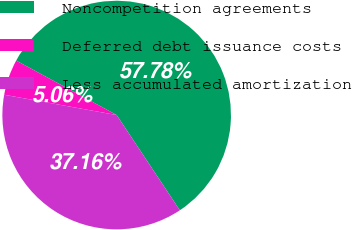<chart> <loc_0><loc_0><loc_500><loc_500><pie_chart><fcel>Noncompetition agreements<fcel>Deferred debt issuance costs<fcel>Less accumulated amortization<nl><fcel>57.78%<fcel>5.06%<fcel>37.16%<nl></chart> 